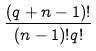Convert formula to latex. <formula><loc_0><loc_0><loc_500><loc_500>\frac { ( q + n - 1 ) ! } { ( n - 1 ) ! q ! }</formula> 